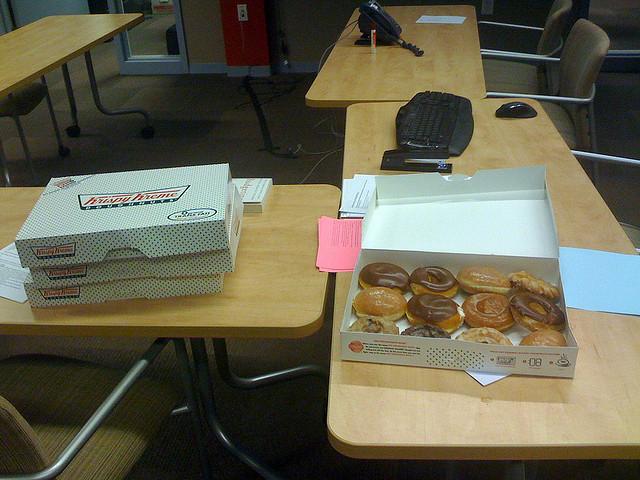What is on the table?
Give a very brief answer. Donuts. What are the words on the red stamp?
Quick response, please. Krispy kreme. Are those donuts for ME???
Give a very brief answer. No. Is there an apple product in this photo?
Quick response, please. No. What is the brand of snack is open?
Concise answer only. Krispy kreme. How many donuts are in the open box?
Quick response, please. 12. How many boxes of donuts are there?
Be succinct. 4. 